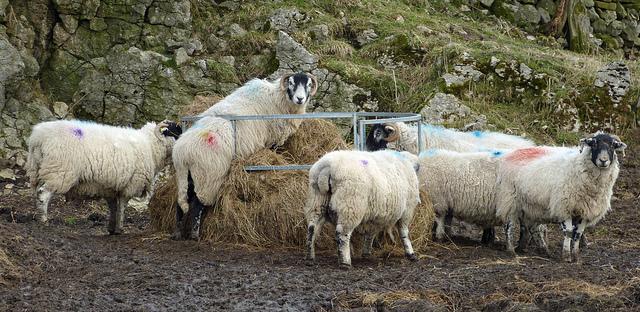What kind of animals are shown?
Give a very brief answer. Sheep. What colors are on the sheep?
Answer briefly. White. What are the animals eating?
Short answer required. Hay. Are children often told that "Mary" was followed to school by a young one of these?
Short answer required. Yes. 